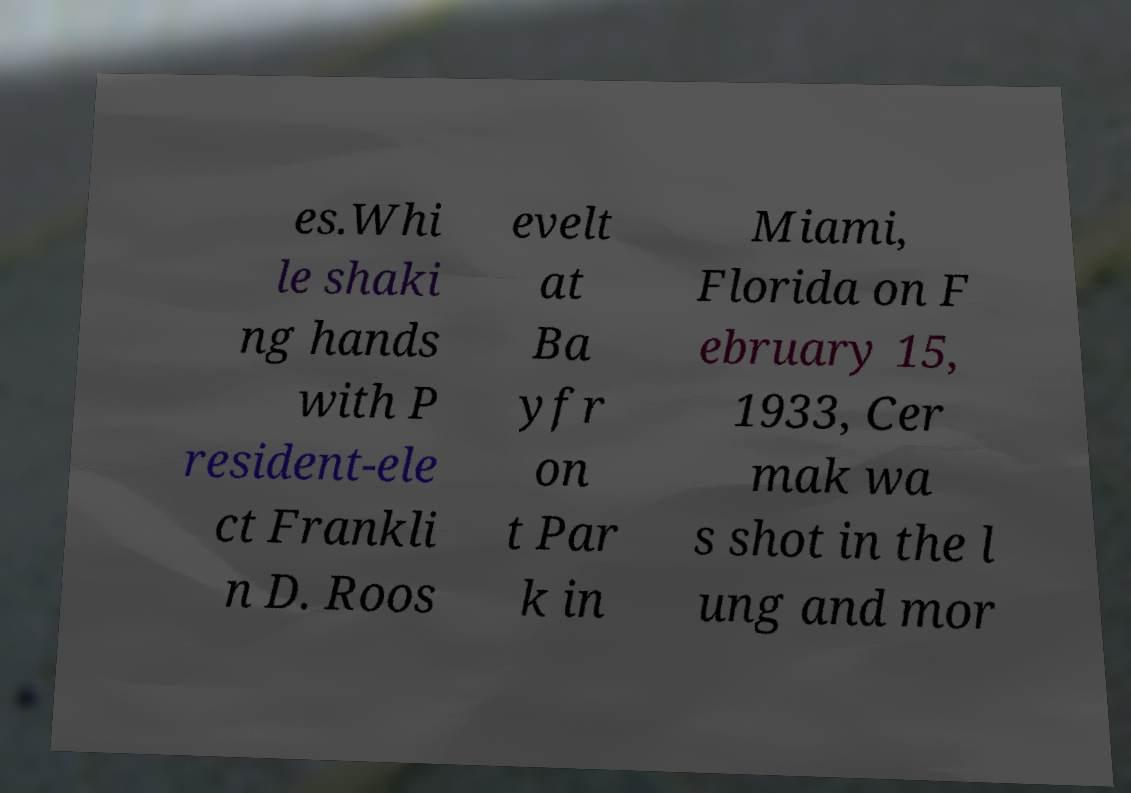There's text embedded in this image that I need extracted. Can you transcribe it verbatim? es.Whi le shaki ng hands with P resident-ele ct Frankli n D. Roos evelt at Ba yfr on t Par k in Miami, Florida on F ebruary 15, 1933, Cer mak wa s shot in the l ung and mor 